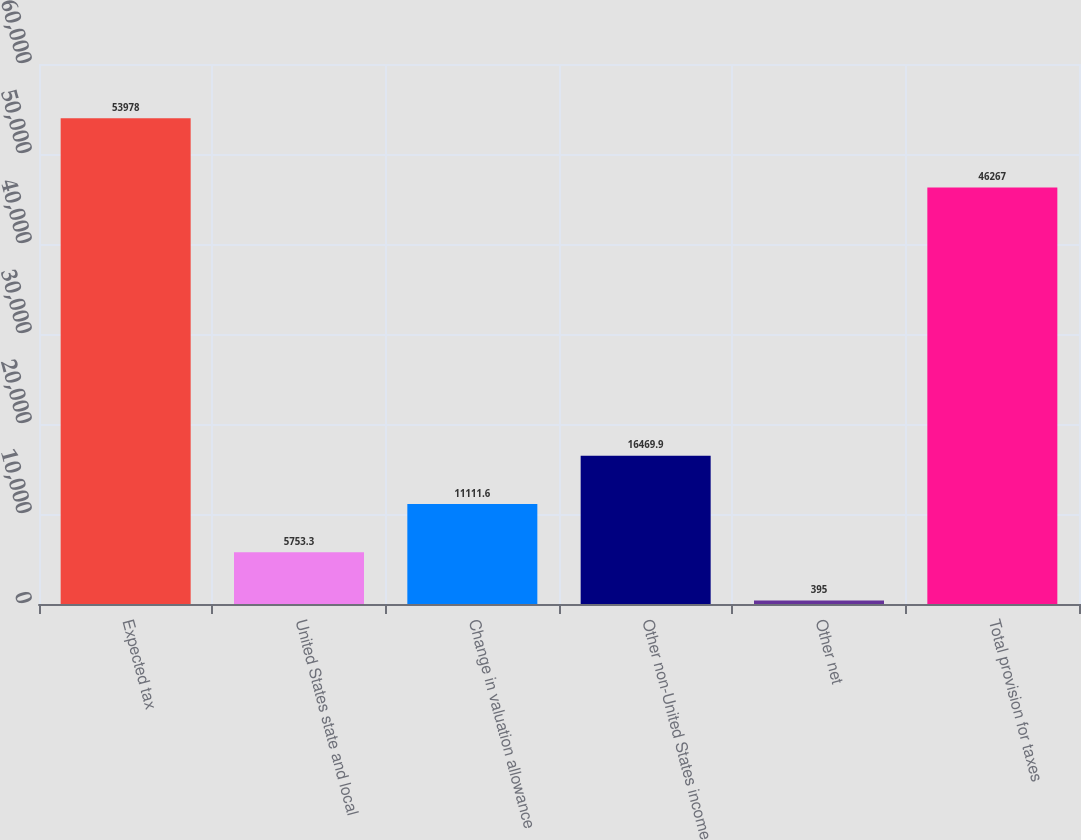<chart> <loc_0><loc_0><loc_500><loc_500><bar_chart><fcel>Expected tax<fcel>United States state and local<fcel>Change in valuation allowance<fcel>Other non-United States income<fcel>Other net<fcel>Total provision for taxes<nl><fcel>53978<fcel>5753.3<fcel>11111.6<fcel>16469.9<fcel>395<fcel>46267<nl></chart> 